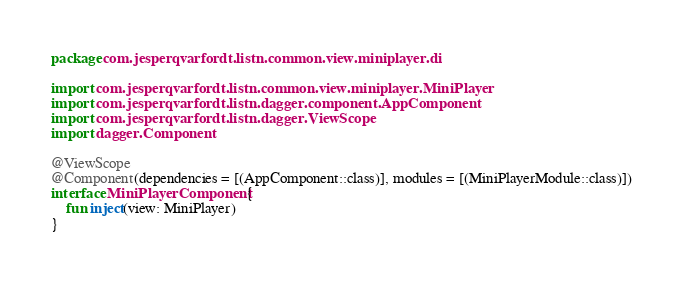Convert code to text. <code><loc_0><loc_0><loc_500><loc_500><_Kotlin_>package com.jesperqvarfordt.listn.common.view.miniplayer.di

import com.jesperqvarfordt.listn.common.view.miniplayer.MiniPlayer
import com.jesperqvarfordt.listn.dagger.component.AppComponent
import com.jesperqvarfordt.listn.dagger.ViewScope
import dagger.Component

@ViewScope
@Component(dependencies = [(AppComponent::class)], modules = [(MiniPlayerModule::class)])
interface MiniPlayerComponent {
    fun inject(view: MiniPlayer)
}</code> 